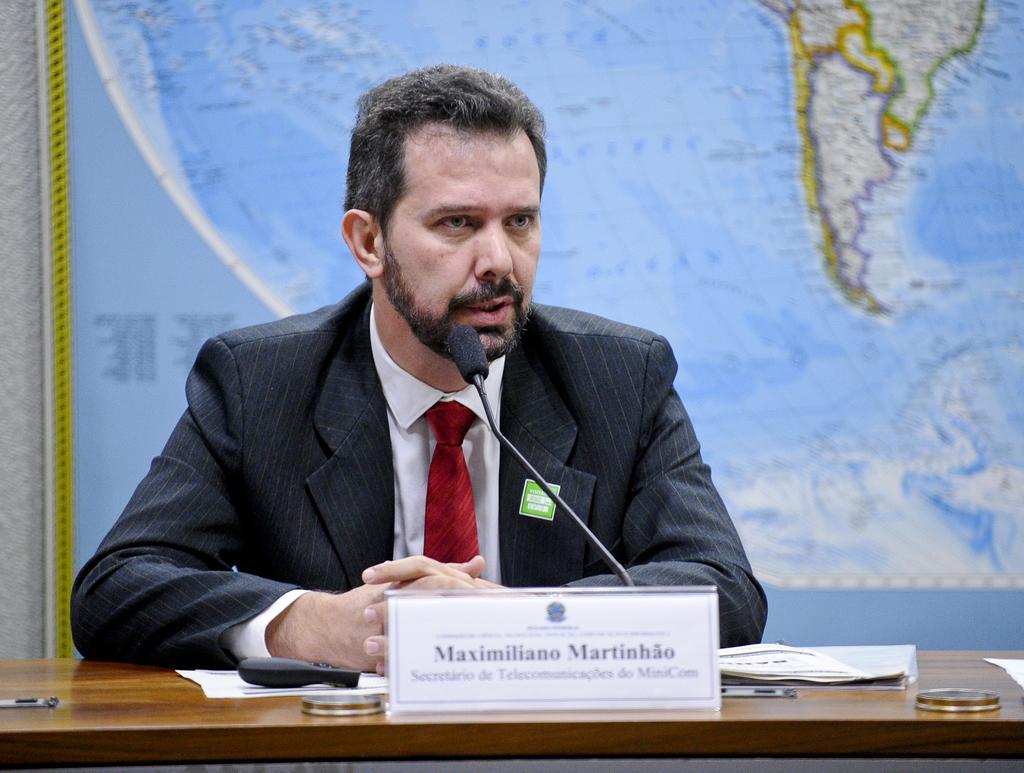Could you give a brief overview of what you see in this image? This image consists of a man wearing a black suit and white shirt along with a red tie is sitting and talking in a mic. In the front, we can see a table. On which there are papers and a name board along with the remote. In the background, there is a banner on a map. 